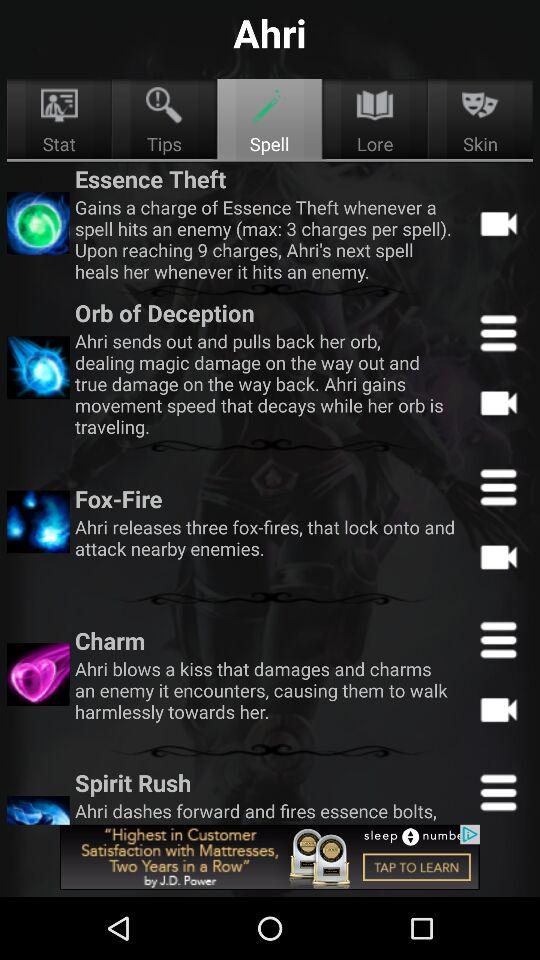How many charges can be gained per spell? The number of charges that can be gained per spell is 3. 